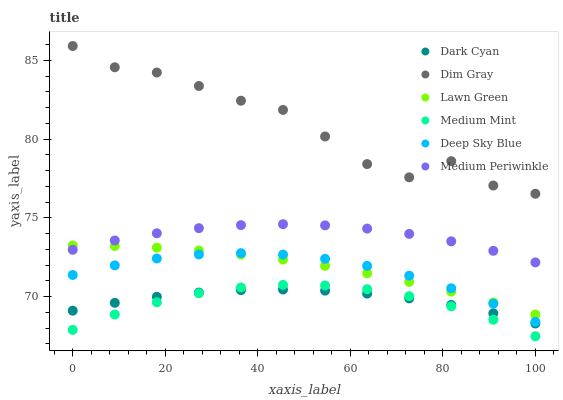Does Medium Mint have the minimum area under the curve?
Answer yes or no. Yes. Does Dim Gray have the maximum area under the curve?
Answer yes or no. Yes. Does Lawn Green have the minimum area under the curve?
Answer yes or no. No. Does Lawn Green have the maximum area under the curve?
Answer yes or no. No. Is Lawn Green the smoothest?
Answer yes or no. Yes. Is Dim Gray the roughest?
Answer yes or no. Yes. Is Dim Gray the smoothest?
Answer yes or no. No. Is Lawn Green the roughest?
Answer yes or no. No. Does Medium Mint have the lowest value?
Answer yes or no. Yes. Does Lawn Green have the lowest value?
Answer yes or no. No. Does Dim Gray have the highest value?
Answer yes or no. Yes. Does Lawn Green have the highest value?
Answer yes or no. No. Is Medium Mint less than Lawn Green?
Answer yes or no. Yes. Is Dim Gray greater than Medium Mint?
Answer yes or no. Yes. Does Lawn Green intersect Deep Sky Blue?
Answer yes or no. Yes. Is Lawn Green less than Deep Sky Blue?
Answer yes or no. No. Is Lawn Green greater than Deep Sky Blue?
Answer yes or no. No. Does Medium Mint intersect Lawn Green?
Answer yes or no. No. 